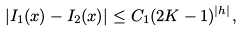Convert formula to latex. <formula><loc_0><loc_0><loc_500><loc_500>| I _ { 1 } ( x ) - I _ { 2 } ( x ) | \leq C _ { 1 } ( 2 K - 1 ) ^ { | h | } ,</formula> 